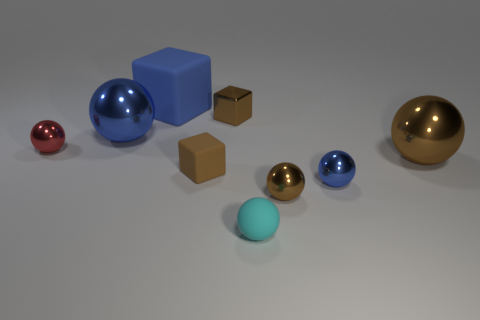Do the tiny rubber cube and the metallic cube have the same color?
Offer a very short reply. Yes. Are there the same number of big things in front of the big brown shiny thing and blue shiny objects to the right of the big blue matte block?
Your answer should be very brief. No. There is a small cube that is the same material as the red object; what color is it?
Your response must be concise. Brown. Is the color of the big matte cube the same as the big thing that is to the left of the blue cube?
Provide a succinct answer. Yes. Is there a tiny brown shiny object in front of the brown sphere on the right side of the blue metal ball to the right of the large matte cube?
Provide a succinct answer. Yes. There is another blue thing that is made of the same material as the small blue thing; what is its shape?
Offer a terse response. Sphere. The blue rubber object has what shape?
Ensure brevity in your answer.  Cube. There is a rubber thing to the right of the tiny brown shiny cube; is its shape the same as the tiny brown rubber thing?
Ensure brevity in your answer.  No. Are there more matte spheres in front of the large matte cube than tiny cyan things left of the large blue metallic ball?
Your answer should be compact. Yes. How many other things are the same size as the brown matte cube?
Provide a succinct answer. 5. 